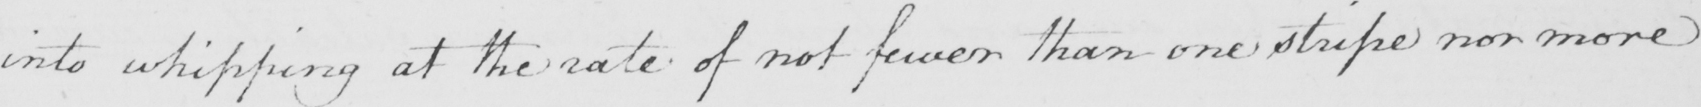What is written in this line of handwriting? into whipping at the rate of not fewer than one stripe nor more 